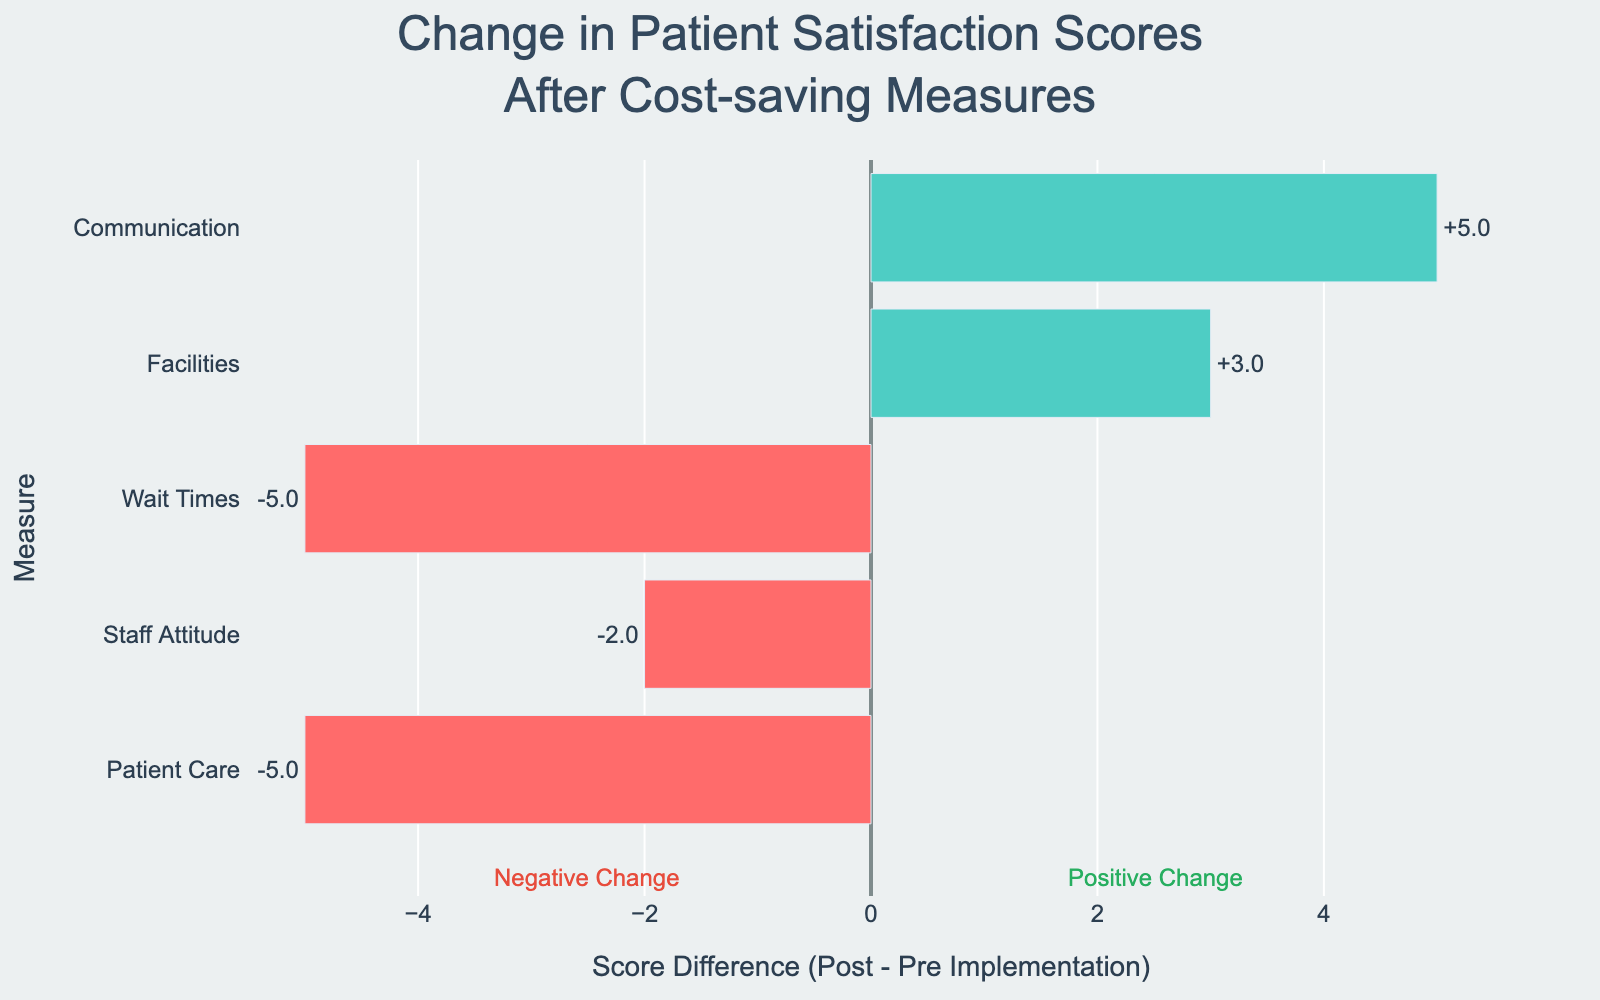Which measure had the highest improvement in patient satisfaction scores after the implementation of cost-saving measures? "Communication" had the highest improvement. By observing the green bar sections that denote positive changes, the Communication measure shows the most significant increase from 80 to 85, resulting in a difference of +5.
Answer: Communication Which measure experienced the most significant drop in patient satisfaction scores? Looking at the red bars, "Wait Times" had the most significant drop. By comparing the bars with negative differences, Wait Times decreased from 70 to 65, reflecting a change of -5.
Answer: Wait Times What is the average change in patient satisfaction scores across all measures? First, calculate the changes for each measure: Patient Care (+2), Staff Attitude (+2), Wait Times (-5), Facilities (+3), and Communication (+5). Then find the average change: (2 + 2 - 5 + 3 + 5) / 5 = 1.4.
Answer: 1.4 Which measures have post-implementation scores greater than their pre-implementation scores? Any positive values on the diverging bar chart indicate post-implementation scores are higher. The measures "Patient Care", "Staff Attitude", "Facilities", and "Communication" show positive bars.
Answer: Patient Care, Staff Attitude, Facilities, Communication What is the overall patient satisfaction trend after cost-saving measures were implemented? Observe the number of green and red bars. With four measures showing improvement (green) and only one showing a decline (red), the overall trend is positive.
Answer: Positive By how much did the "Facilities" score change after implementing the cost-saving measures? Compare the pre-implementation and post-implementation scores for "Facilities". They changed from 75 to 78, resulting in a difference of +3.
Answer: +3 What was the score change for the measure "Patient Care" before and after the cost-saving measures were applied? The pre-implementation score for "Patient Care" was 85, and the post-implementation score was 80, leading to a difference of -5.
Answer: -5 Which measure had the smallest positive change? Compare the positive changes: "Patient Care" (+2) and "Staff Attitude" (+2) are the smallest positive changes but equal.
Answer: Patient Care, Staff Attitude How did the patient satisfaction score for "Staff Attitude" change after cost-saving measures were implemented? The pre-implementation score for "Staff Attitude" was 90, and the post-implementation score was 88, resulting in a change of -2.
Answer: -2 